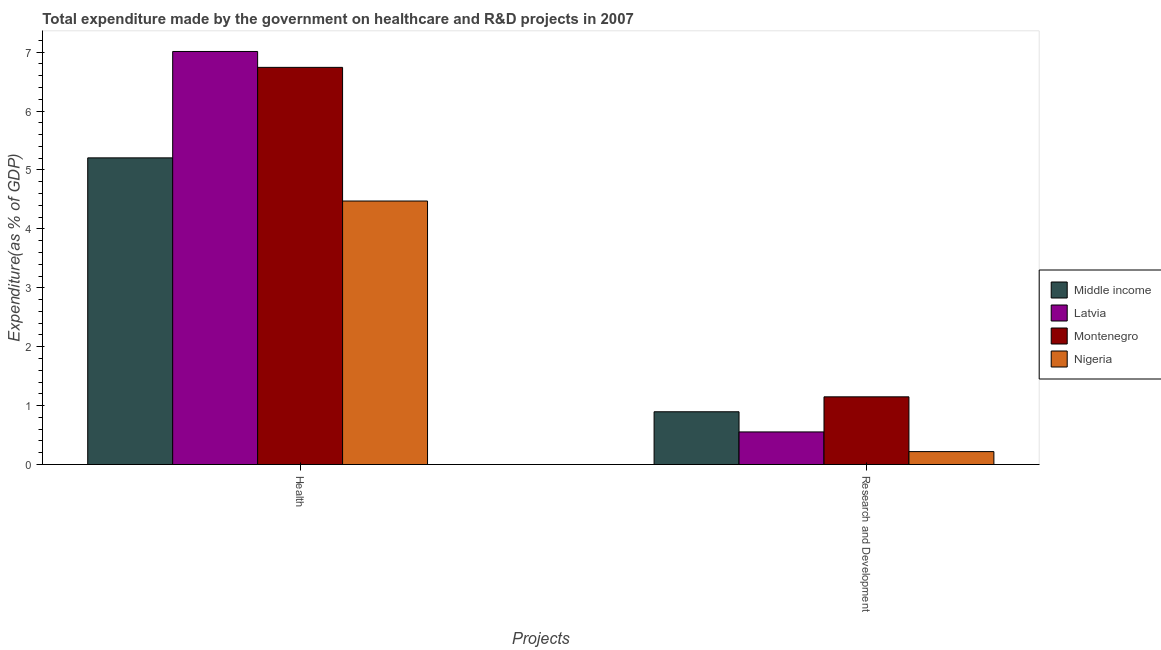How many different coloured bars are there?
Offer a terse response. 4. How many groups of bars are there?
Provide a succinct answer. 2. Are the number of bars per tick equal to the number of legend labels?
Keep it short and to the point. Yes. Are the number of bars on each tick of the X-axis equal?
Provide a short and direct response. Yes. How many bars are there on the 2nd tick from the left?
Keep it short and to the point. 4. How many bars are there on the 1st tick from the right?
Keep it short and to the point. 4. What is the label of the 2nd group of bars from the left?
Make the answer very short. Research and Development. What is the expenditure in healthcare in Nigeria?
Your answer should be very brief. 4.47. Across all countries, what is the maximum expenditure in healthcare?
Make the answer very short. 7.01. Across all countries, what is the minimum expenditure in healthcare?
Provide a short and direct response. 4.47. In which country was the expenditure in r&d maximum?
Give a very brief answer. Montenegro. In which country was the expenditure in r&d minimum?
Provide a succinct answer. Nigeria. What is the total expenditure in r&d in the graph?
Your answer should be very brief. 2.82. What is the difference between the expenditure in r&d in Latvia and that in Montenegro?
Provide a short and direct response. -0.6. What is the difference between the expenditure in r&d in Nigeria and the expenditure in healthcare in Middle income?
Ensure brevity in your answer.  -4.99. What is the average expenditure in healthcare per country?
Provide a short and direct response. 5.86. What is the difference between the expenditure in r&d and expenditure in healthcare in Nigeria?
Keep it short and to the point. -4.25. What is the ratio of the expenditure in r&d in Latvia to that in Middle income?
Provide a succinct answer. 0.62. Is the expenditure in healthcare in Latvia less than that in Nigeria?
Provide a short and direct response. No. What does the 2nd bar from the left in Research and Development represents?
Provide a short and direct response. Latvia. What does the 3rd bar from the right in Health represents?
Give a very brief answer. Latvia. Are all the bars in the graph horizontal?
Make the answer very short. No. Does the graph contain any zero values?
Make the answer very short. No. Does the graph contain grids?
Provide a short and direct response. No. How many legend labels are there?
Keep it short and to the point. 4. What is the title of the graph?
Your response must be concise. Total expenditure made by the government on healthcare and R&D projects in 2007. Does "Other small states" appear as one of the legend labels in the graph?
Make the answer very short. No. What is the label or title of the X-axis?
Your answer should be very brief. Projects. What is the label or title of the Y-axis?
Your answer should be compact. Expenditure(as % of GDP). What is the Expenditure(as % of GDP) in Middle income in Health?
Offer a terse response. 5.21. What is the Expenditure(as % of GDP) in Latvia in Health?
Your answer should be very brief. 7.01. What is the Expenditure(as % of GDP) in Montenegro in Health?
Keep it short and to the point. 6.74. What is the Expenditure(as % of GDP) in Nigeria in Health?
Offer a very short reply. 4.47. What is the Expenditure(as % of GDP) of Middle income in Research and Development?
Offer a terse response. 0.9. What is the Expenditure(as % of GDP) in Latvia in Research and Development?
Give a very brief answer. 0.55. What is the Expenditure(as % of GDP) of Montenegro in Research and Development?
Provide a short and direct response. 1.15. What is the Expenditure(as % of GDP) of Nigeria in Research and Development?
Your answer should be compact. 0.22. Across all Projects, what is the maximum Expenditure(as % of GDP) in Middle income?
Give a very brief answer. 5.21. Across all Projects, what is the maximum Expenditure(as % of GDP) in Latvia?
Your response must be concise. 7.01. Across all Projects, what is the maximum Expenditure(as % of GDP) in Montenegro?
Your answer should be very brief. 6.74. Across all Projects, what is the maximum Expenditure(as % of GDP) in Nigeria?
Give a very brief answer. 4.47. Across all Projects, what is the minimum Expenditure(as % of GDP) in Middle income?
Give a very brief answer. 0.9. Across all Projects, what is the minimum Expenditure(as % of GDP) of Latvia?
Provide a short and direct response. 0.55. Across all Projects, what is the minimum Expenditure(as % of GDP) of Montenegro?
Make the answer very short. 1.15. Across all Projects, what is the minimum Expenditure(as % of GDP) in Nigeria?
Keep it short and to the point. 0.22. What is the total Expenditure(as % of GDP) of Middle income in the graph?
Offer a terse response. 6.1. What is the total Expenditure(as % of GDP) of Latvia in the graph?
Your answer should be very brief. 7.57. What is the total Expenditure(as % of GDP) of Montenegro in the graph?
Your answer should be compact. 7.89. What is the total Expenditure(as % of GDP) in Nigeria in the graph?
Keep it short and to the point. 4.69. What is the difference between the Expenditure(as % of GDP) in Middle income in Health and that in Research and Development?
Provide a short and direct response. 4.31. What is the difference between the Expenditure(as % of GDP) in Latvia in Health and that in Research and Development?
Offer a terse response. 6.46. What is the difference between the Expenditure(as % of GDP) in Montenegro in Health and that in Research and Development?
Offer a terse response. 5.59. What is the difference between the Expenditure(as % of GDP) in Nigeria in Health and that in Research and Development?
Ensure brevity in your answer.  4.25. What is the difference between the Expenditure(as % of GDP) of Middle income in Health and the Expenditure(as % of GDP) of Latvia in Research and Development?
Your response must be concise. 4.65. What is the difference between the Expenditure(as % of GDP) in Middle income in Health and the Expenditure(as % of GDP) in Montenegro in Research and Development?
Offer a terse response. 4.06. What is the difference between the Expenditure(as % of GDP) of Middle income in Health and the Expenditure(as % of GDP) of Nigeria in Research and Development?
Ensure brevity in your answer.  4.99. What is the difference between the Expenditure(as % of GDP) of Latvia in Health and the Expenditure(as % of GDP) of Montenegro in Research and Development?
Keep it short and to the point. 5.86. What is the difference between the Expenditure(as % of GDP) in Latvia in Health and the Expenditure(as % of GDP) in Nigeria in Research and Development?
Make the answer very short. 6.79. What is the difference between the Expenditure(as % of GDP) in Montenegro in Health and the Expenditure(as % of GDP) in Nigeria in Research and Development?
Offer a very short reply. 6.52. What is the average Expenditure(as % of GDP) in Middle income per Projects?
Make the answer very short. 3.05. What is the average Expenditure(as % of GDP) of Latvia per Projects?
Your answer should be very brief. 3.78. What is the average Expenditure(as % of GDP) of Montenegro per Projects?
Provide a succinct answer. 3.95. What is the average Expenditure(as % of GDP) of Nigeria per Projects?
Your response must be concise. 2.35. What is the difference between the Expenditure(as % of GDP) of Middle income and Expenditure(as % of GDP) of Latvia in Health?
Your answer should be compact. -1.81. What is the difference between the Expenditure(as % of GDP) of Middle income and Expenditure(as % of GDP) of Montenegro in Health?
Make the answer very short. -1.54. What is the difference between the Expenditure(as % of GDP) in Middle income and Expenditure(as % of GDP) in Nigeria in Health?
Make the answer very short. 0.73. What is the difference between the Expenditure(as % of GDP) in Latvia and Expenditure(as % of GDP) in Montenegro in Health?
Offer a very short reply. 0.27. What is the difference between the Expenditure(as % of GDP) of Latvia and Expenditure(as % of GDP) of Nigeria in Health?
Provide a succinct answer. 2.54. What is the difference between the Expenditure(as % of GDP) in Montenegro and Expenditure(as % of GDP) in Nigeria in Health?
Your answer should be compact. 2.27. What is the difference between the Expenditure(as % of GDP) in Middle income and Expenditure(as % of GDP) in Latvia in Research and Development?
Offer a terse response. 0.34. What is the difference between the Expenditure(as % of GDP) of Middle income and Expenditure(as % of GDP) of Montenegro in Research and Development?
Offer a terse response. -0.25. What is the difference between the Expenditure(as % of GDP) of Middle income and Expenditure(as % of GDP) of Nigeria in Research and Development?
Your response must be concise. 0.68. What is the difference between the Expenditure(as % of GDP) of Latvia and Expenditure(as % of GDP) of Montenegro in Research and Development?
Offer a terse response. -0.6. What is the difference between the Expenditure(as % of GDP) of Latvia and Expenditure(as % of GDP) of Nigeria in Research and Development?
Provide a short and direct response. 0.33. What is the difference between the Expenditure(as % of GDP) in Montenegro and Expenditure(as % of GDP) in Nigeria in Research and Development?
Your answer should be compact. 0.93. What is the ratio of the Expenditure(as % of GDP) in Middle income in Health to that in Research and Development?
Offer a terse response. 5.81. What is the ratio of the Expenditure(as % of GDP) in Latvia in Health to that in Research and Development?
Offer a terse response. 12.68. What is the ratio of the Expenditure(as % of GDP) of Montenegro in Health to that in Research and Development?
Offer a terse response. 5.87. What is the ratio of the Expenditure(as % of GDP) in Nigeria in Health to that in Research and Development?
Your answer should be very brief. 20.43. What is the difference between the highest and the second highest Expenditure(as % of GDP) in Middle income?
Give a very brief answer. 4.31. What is the difference between the highest and the second highest Expenditure(as % of GDP) of Latvia?
Give a very brief answer. 6.46. What is the difference between the highest and the second highest Expenditure(as % of GDP) of Montenegro?
Offer a very short reply. 5.59. What is the difference between the highest and the second highest Expenditure(as % of GDP) in Nigeria?
Your response must be concise. 4.25. What is the difference between the highest and the lowest Expenditure(as % of GDP) in Middle income?
Your answer should be very brief. 4.31. What is the difference between the highest and the lowest Expenditure(as % of GDP) in Latvia?
Give a very brief answer. 6.46. What is the difference between the highest and the lowest Expenditure(as % of GDP) of Montenegro?
Keep it short and to the point. 5.59. What is the difference between the highest and the lowest Expenditure(as % of GDP) of Nigeria?
Keep it short and to the point. 4.25. 